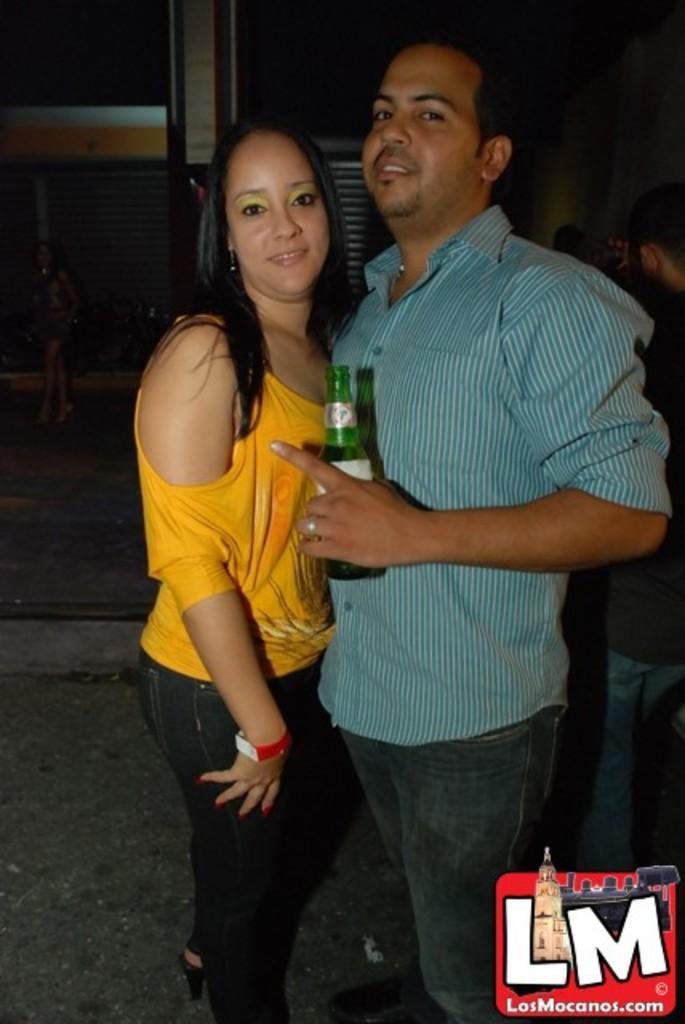Can you describe this image briefly? In this image we can see two people are standing and posing for a photo and among them one person holding a bottle and there are few people in the background and we can see a building. 